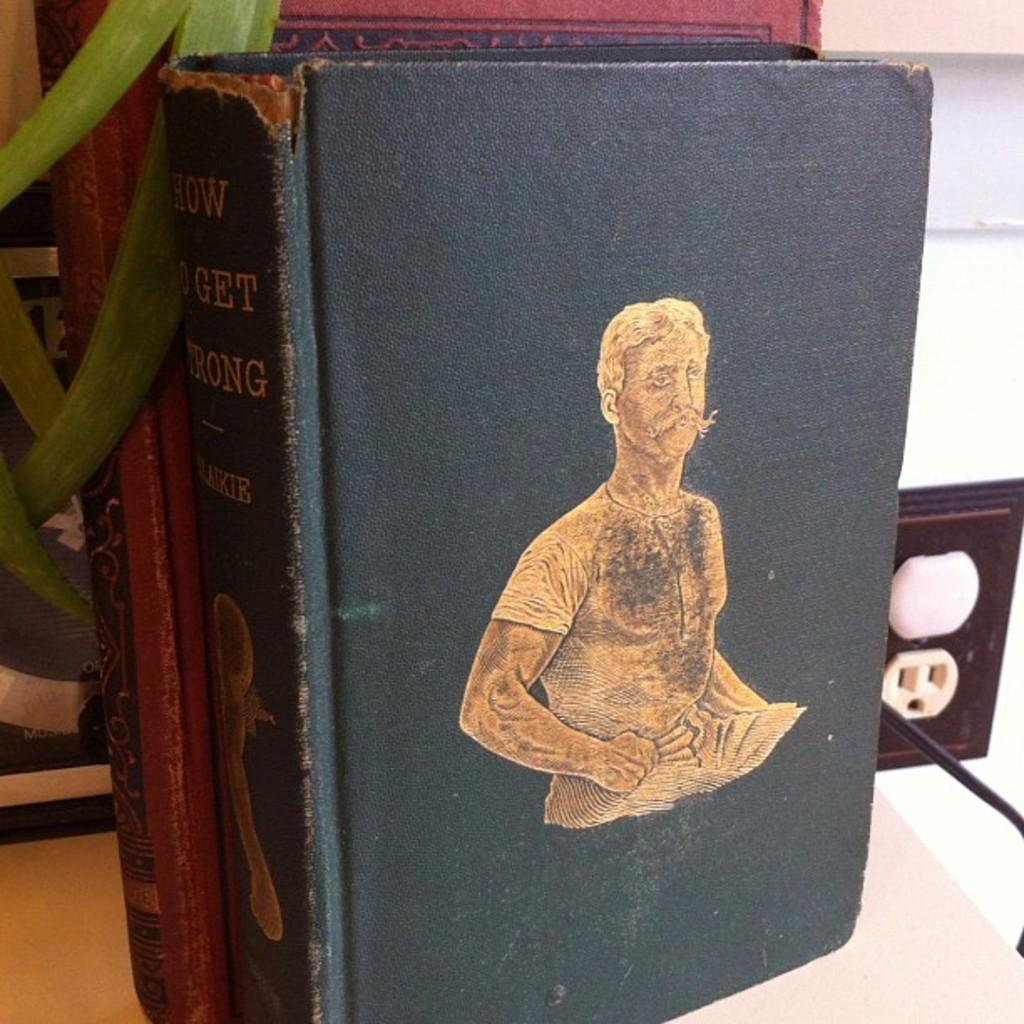<image>
Create a compact narrative representing the image presented. A book titled How to get strong on a table. 